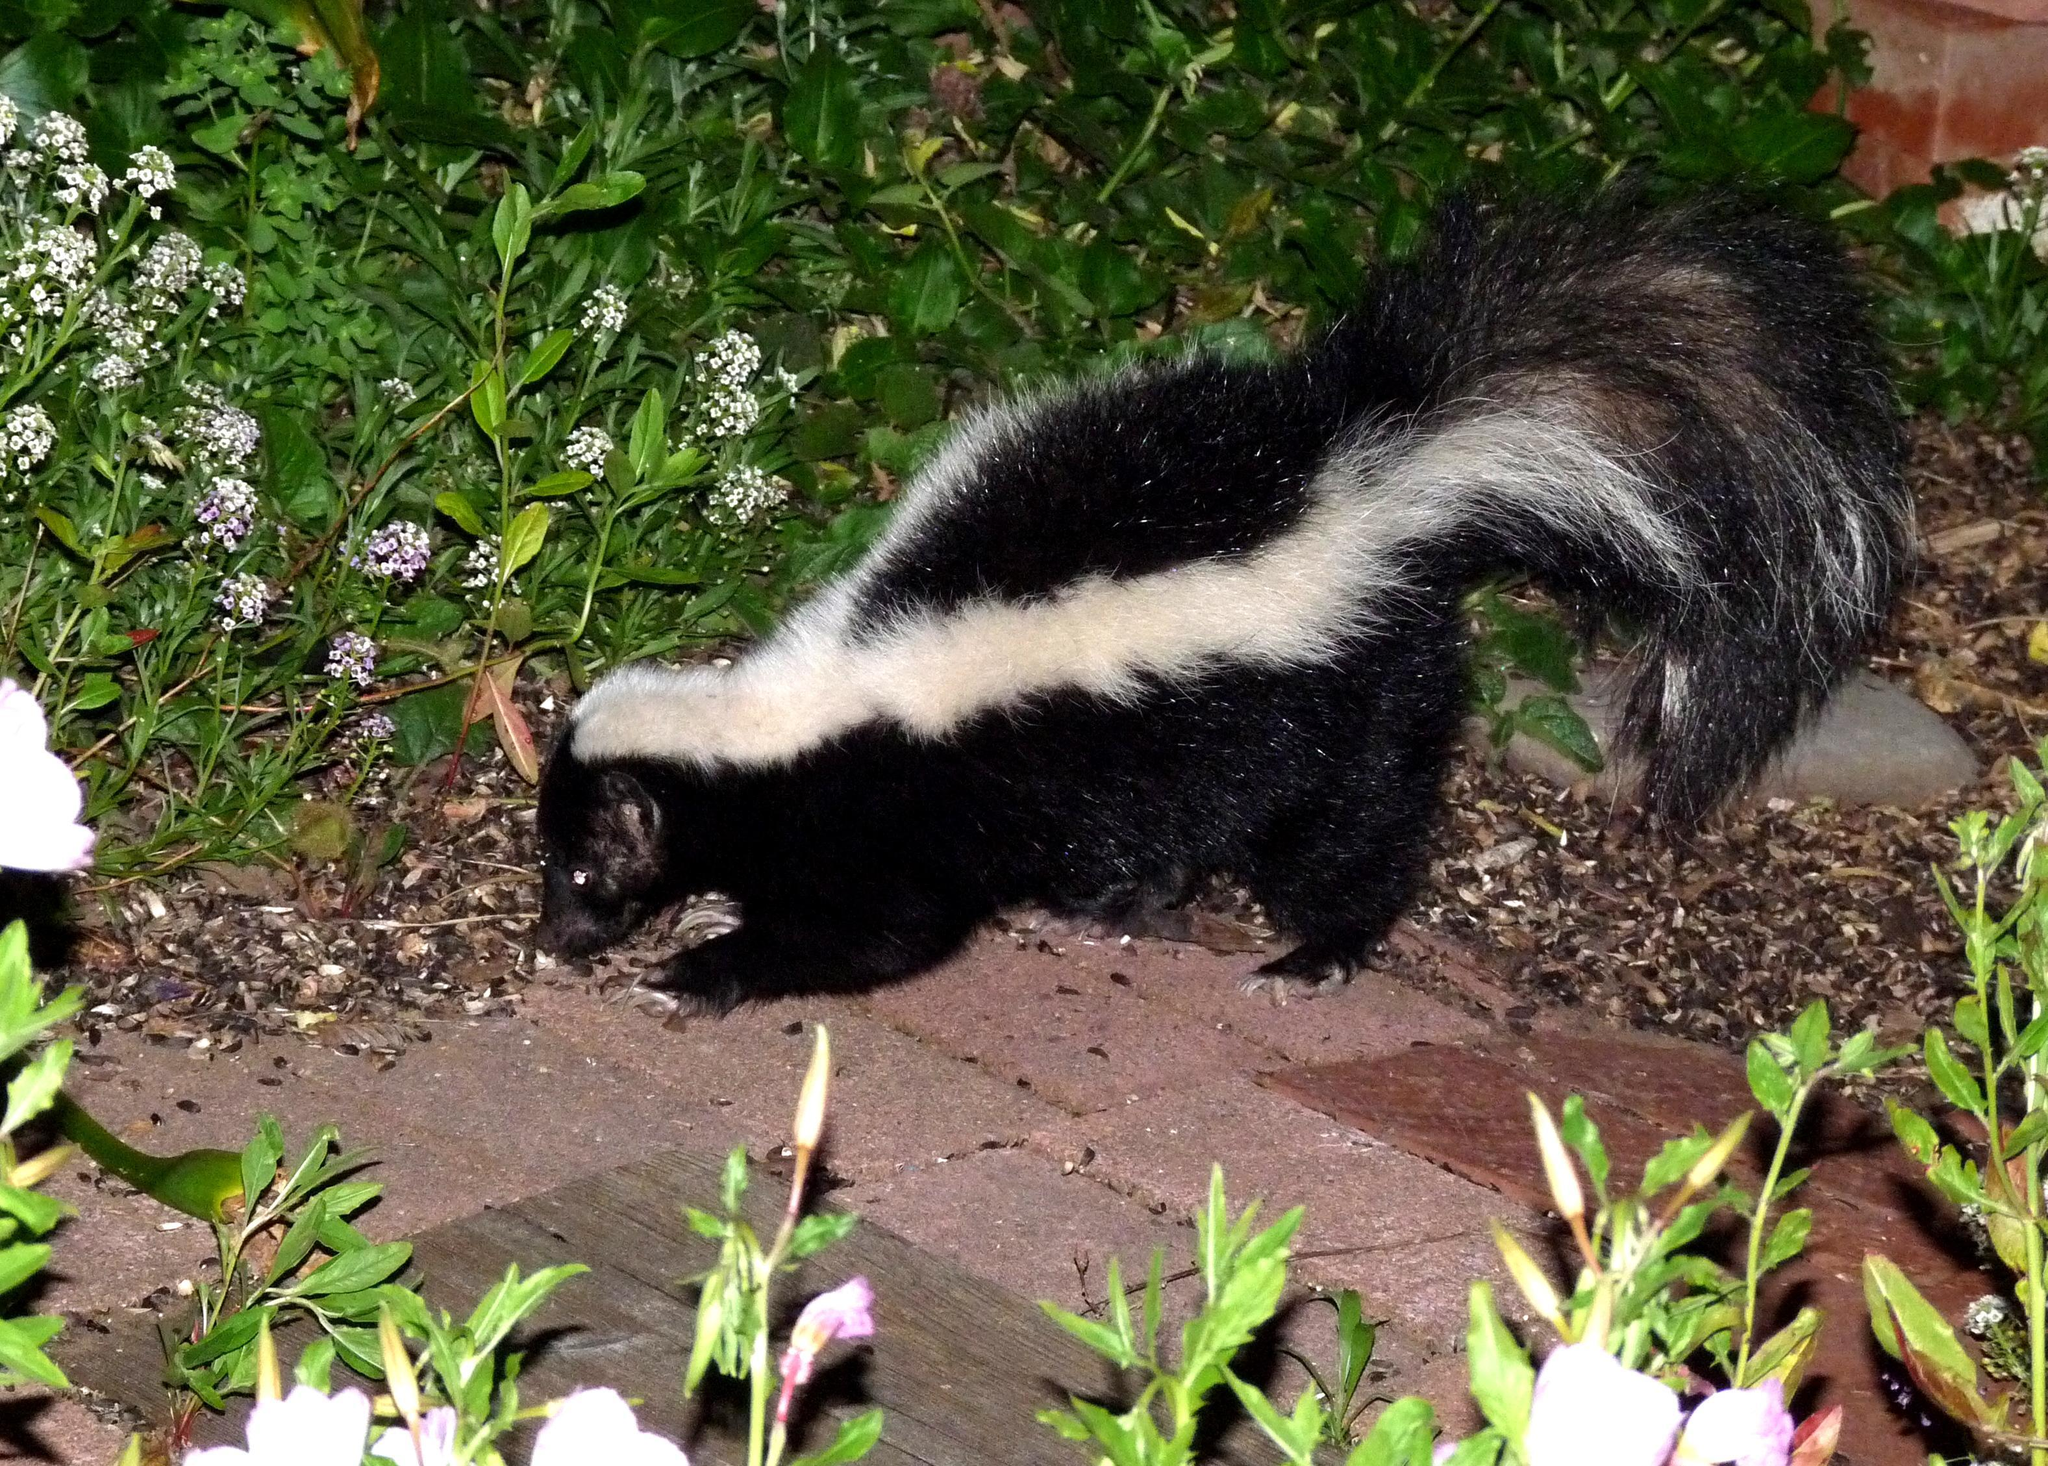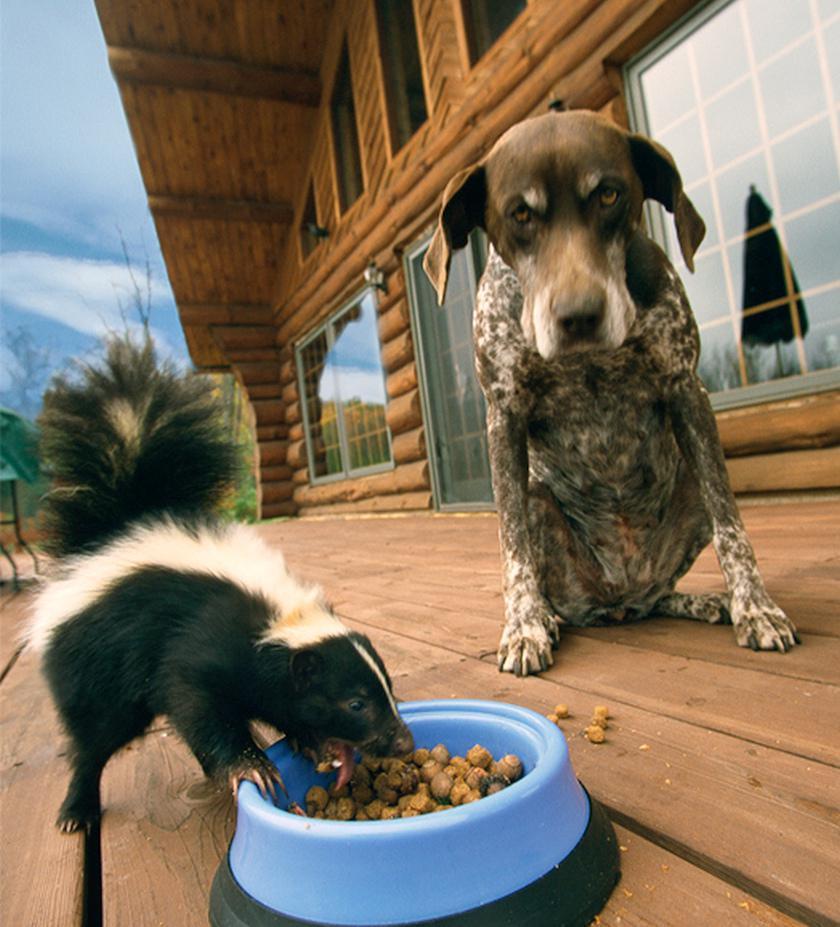The first image is the image on the left, the second image is the image on the right. Considering the images on both sides, is "In one of the images an animal can be seen eating dog food." valid? Answer yes or no. Yes. The first image is the image on the left, the second image is the image on the right. Assess this claim about the two images: "One of the images has a skunk along with a an animal that is not a skunk.". Correct or not? Answer yes or no. Yes. 